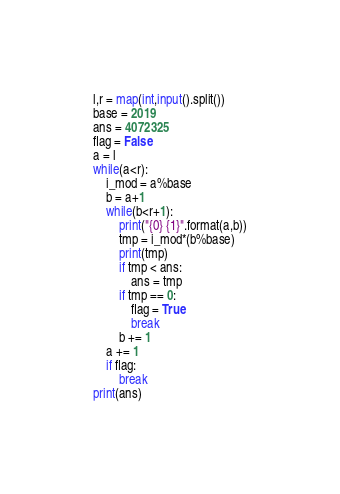<code> <loc_0><loc_0><loc_500><loc_500><_Python_>l,r = map(int,input().split())
base = 2019
ans = 4072325
flag = False
a = l
while(a<r):
    i_mod = a%base
    b = a+1
    while(b<r+1):
        print("{0} {1}".format(a,b))
        tmp = i_mod*(b%base)
        print(tmp)
        if tmp < ans:
            ans = tmp
        if tmp == 0:
            flag = True
            break
        b += 1
    a += 1
    if flag:
        break
print(ans)</code> 